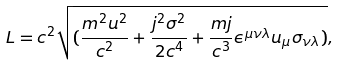Convert formula to latex. <formula><loc_0><loc_0><loc_500><loc_500>L = c ^ { 2 } \sqrt { ( \frac { m ^ { 2 } u ^ { 2 } } { c ^ { 2 } } + \frac { j ^ { 2 } \sigma ^ { 2 } } { 2 c ^ { 4 } } + \frac { m j } { c ^ { 3 } } \epsilon ^ { \mu \nu \lambda } u _ { \mu } \sigma _ { \nu \lambda } ) } ,</formula> 